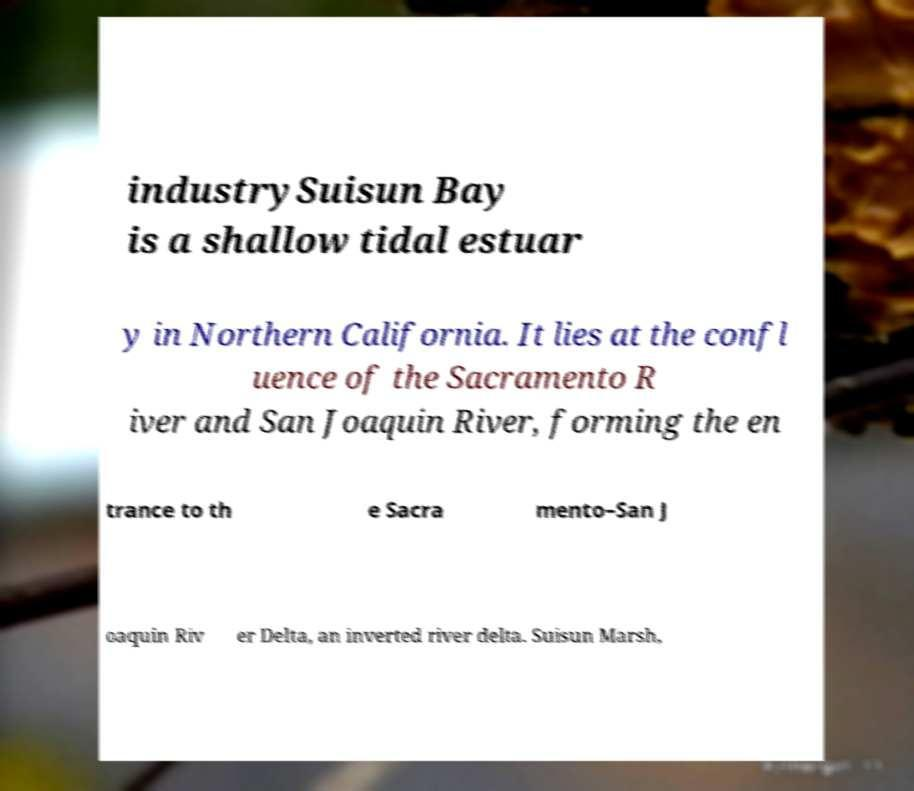Could you assist in decoding the text presented in this image and type it out clearly? industrySuisun Bay is a shallow tidal estuar y in Northern California. It lies at the confl uence of the Sacramento R iver and San Joaquin River, forming the en trance to th e Sacra mento–San J oaquin Riv er Delta, an inverted river delta. Suisun Marsh, 